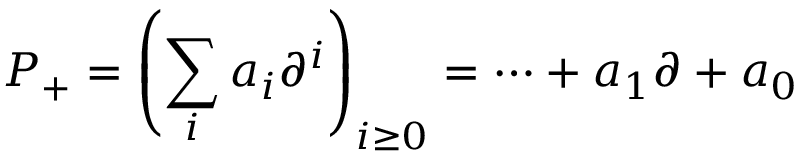Convert formula to latex. <formula><loc_0><loc_0><loc_500><loc_500>P _ { + } = \left ( \sum _ { i } a _ { i } \partial ^ { i } \right ) _ { i \geq 0 } = \cdots + a _ { 1 } \partial + a _ { 0 }</formula> 